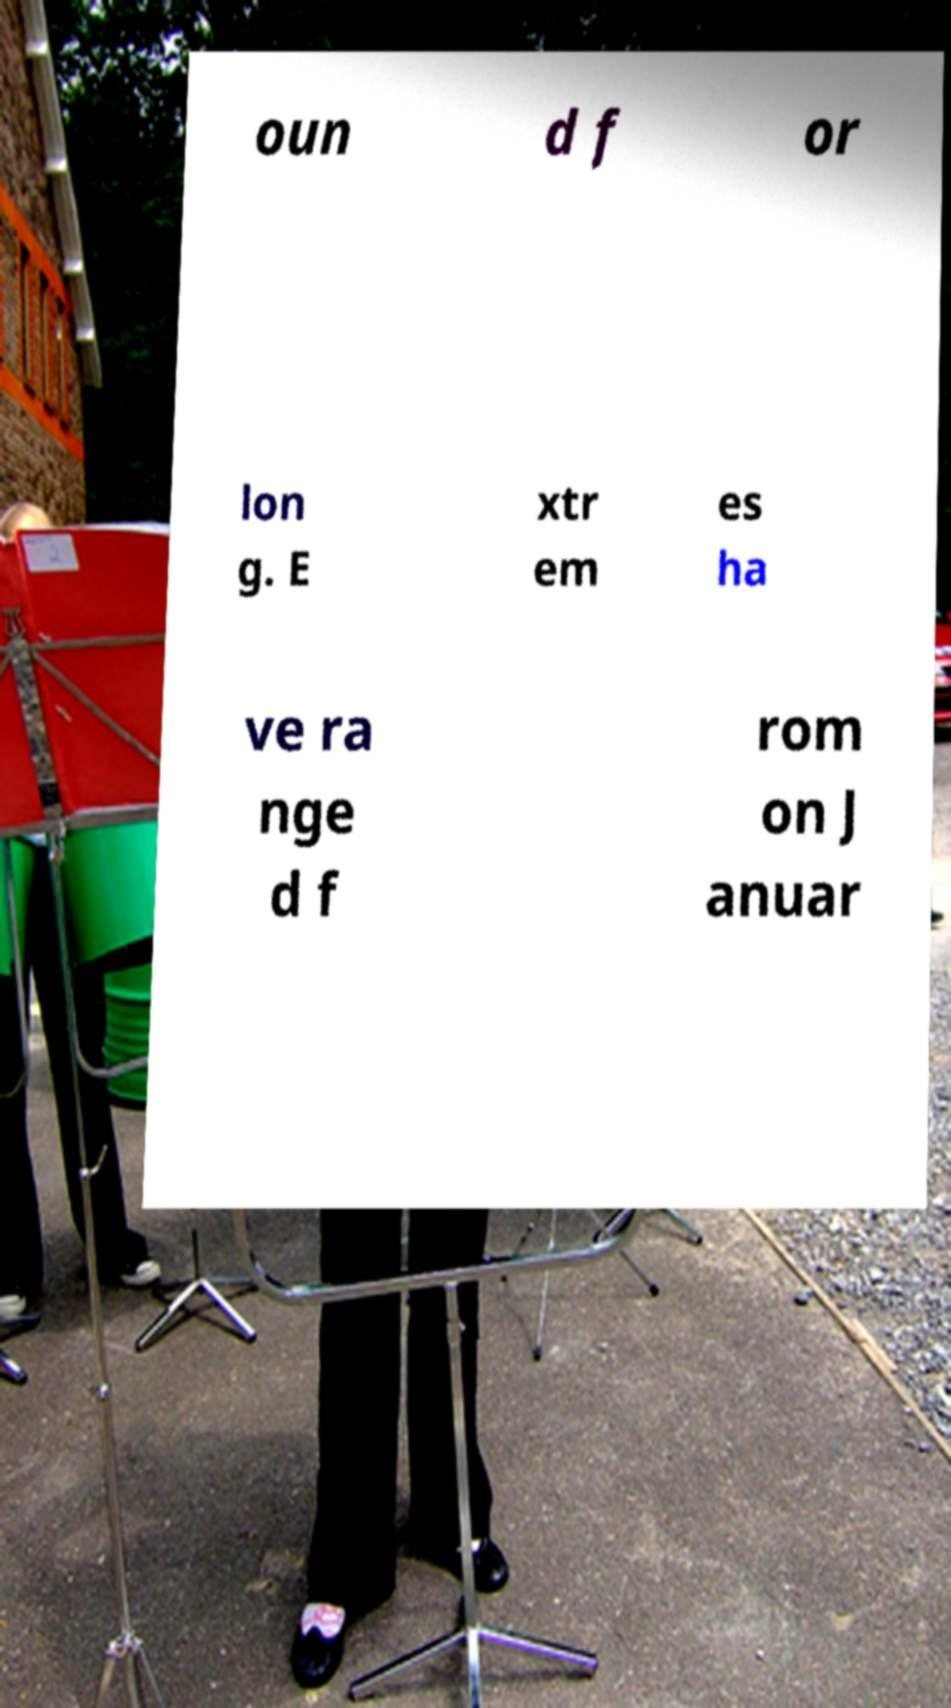There's text embedded in this image that I need extracted. Can you transcribe it verbatim? oun d f or lon g. E xtr em es ha ve ra nge d f rom on J anuar 